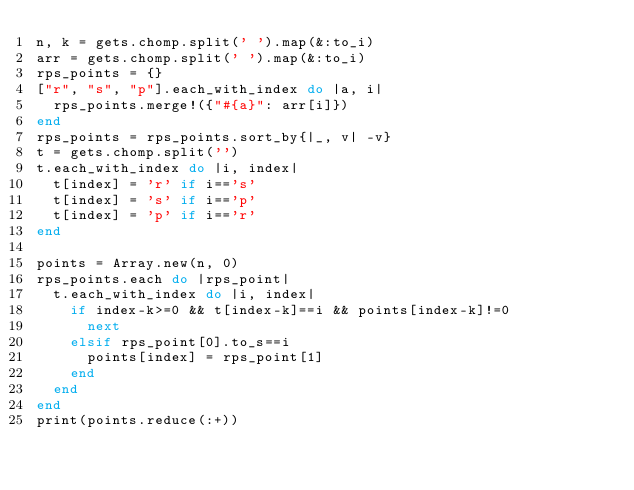Convert code to text. <code><loc_0><loc_0><loc_500><loc_500><_Ruby_>n, k = gets.chomp.split(' ').map(&:to_i)
arr = gets.chomp.split(' ').map(&:to_i)
rps_points = {}
["r", "s", "p"].each_with_index do |a, i|
  rps_points.merge!({"#{a}": arr[i]})
end
rps_points = rps_points.sort_by{|_, v| -v}
t = gets.chomp.split('')
t.each_with_index do |i, index|
  t[index] = 'r' if i=='s'
  t[index] = 's' if i=='p'
  t[index] = 'p' if i=='r'
end

points = Array.new(n, 0)
rps_points.each do |rps_point|  
  t.each_with_index do |i, index|
    if index-k>=0 && t[index-k]==i && points[index-k]!=0
      next
    elsif rps_point[0].to_s==i
      points[index] = rps_point[1]
    end
  end
end
print(points.reduce(:+))</code> 